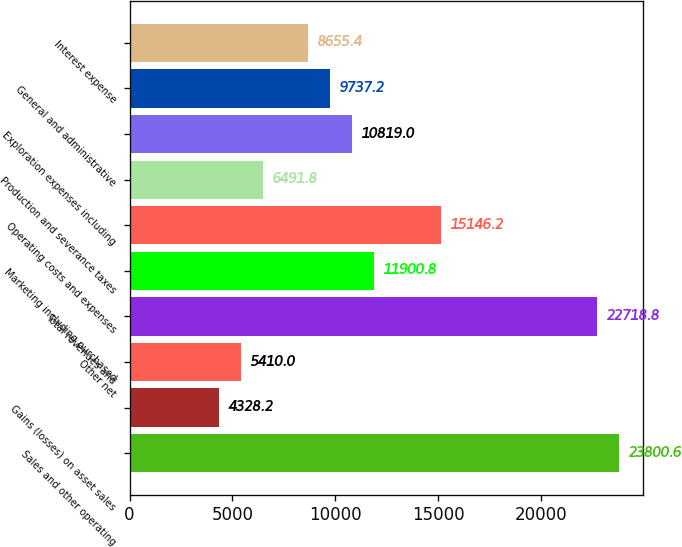<chart> <loc_0><loc_0><loc_500><loc_500><bar_chart><fcel>Sales and other operating<fcel>Gains (losses) on asset sales<fcel>Other net<fcel>Total revenues and<fcel>Marketing including purchased<fcel>Operating costs and expenses<fcel>Production and severance taxes<fcel>Exploration expenses including<fcel>General and administrative<fcel>Interest expense<nl><fcel>23800.6<fcel>4328.2<fcel>5410<fcel>22718.8<fcel>11900.8<fcel>15146.2<fcel>6491.8<fcel>10819<fcel>9737.2<fcel>8655.4<nl></chart> 